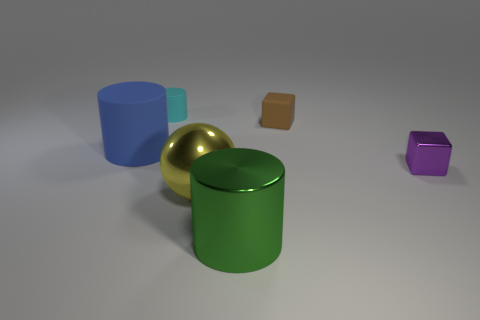Add 3 small cylinders. How many objects exist? 9 Subtract all blocks. How many objects are left? 4 Add 2 big yellow metal balls. How many big yellow metal balls are left? 3 Add 2 shiny spheres. How many shiny spheres exist? 3 Subtract 0 blue cubes. How many objects are left? 6 Subtract all small spheres. Subtract all brown matte cubes. How many objects are left? 5 